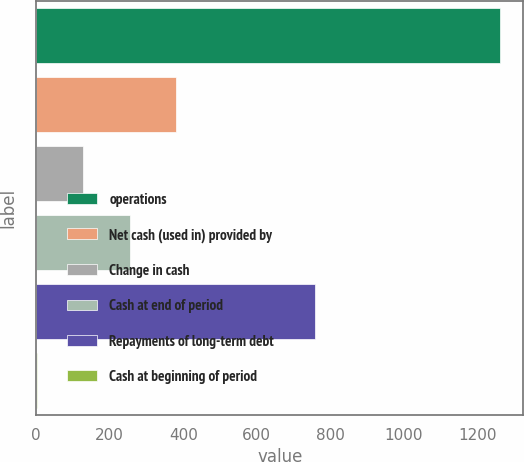Convert chart. <chart><loc_0><loc_0><loc_500><loc_500><bar_chart><fcel>operations<fcel>Net cash (used in) provided by<fcel>Change in cash<fcel>Cash at end of period<fcel>Repayments of long-term debt<fcel>Cash at beginning of period<nl><fcel>1262<fcel>380<fcel>128<fcel>254<fcel>758<fcel>2<nl></chart> 